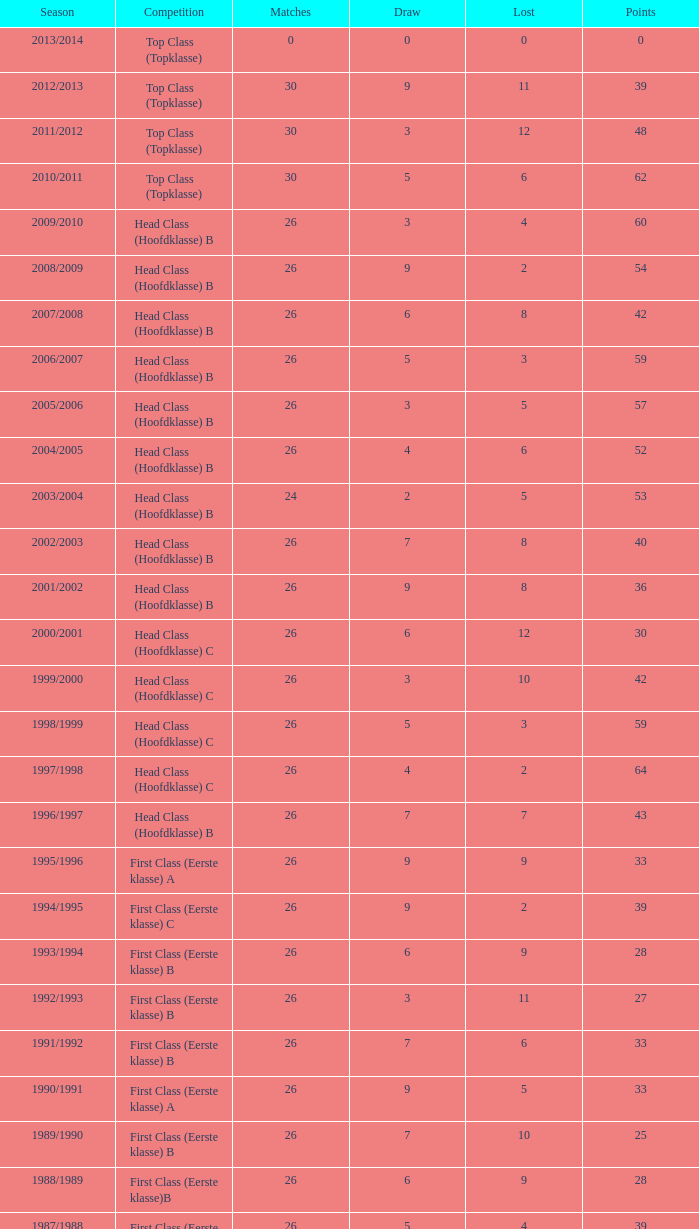Calculate the combined losses for a match score above 26, a points score of 62, and a draw higher than 5. None. 